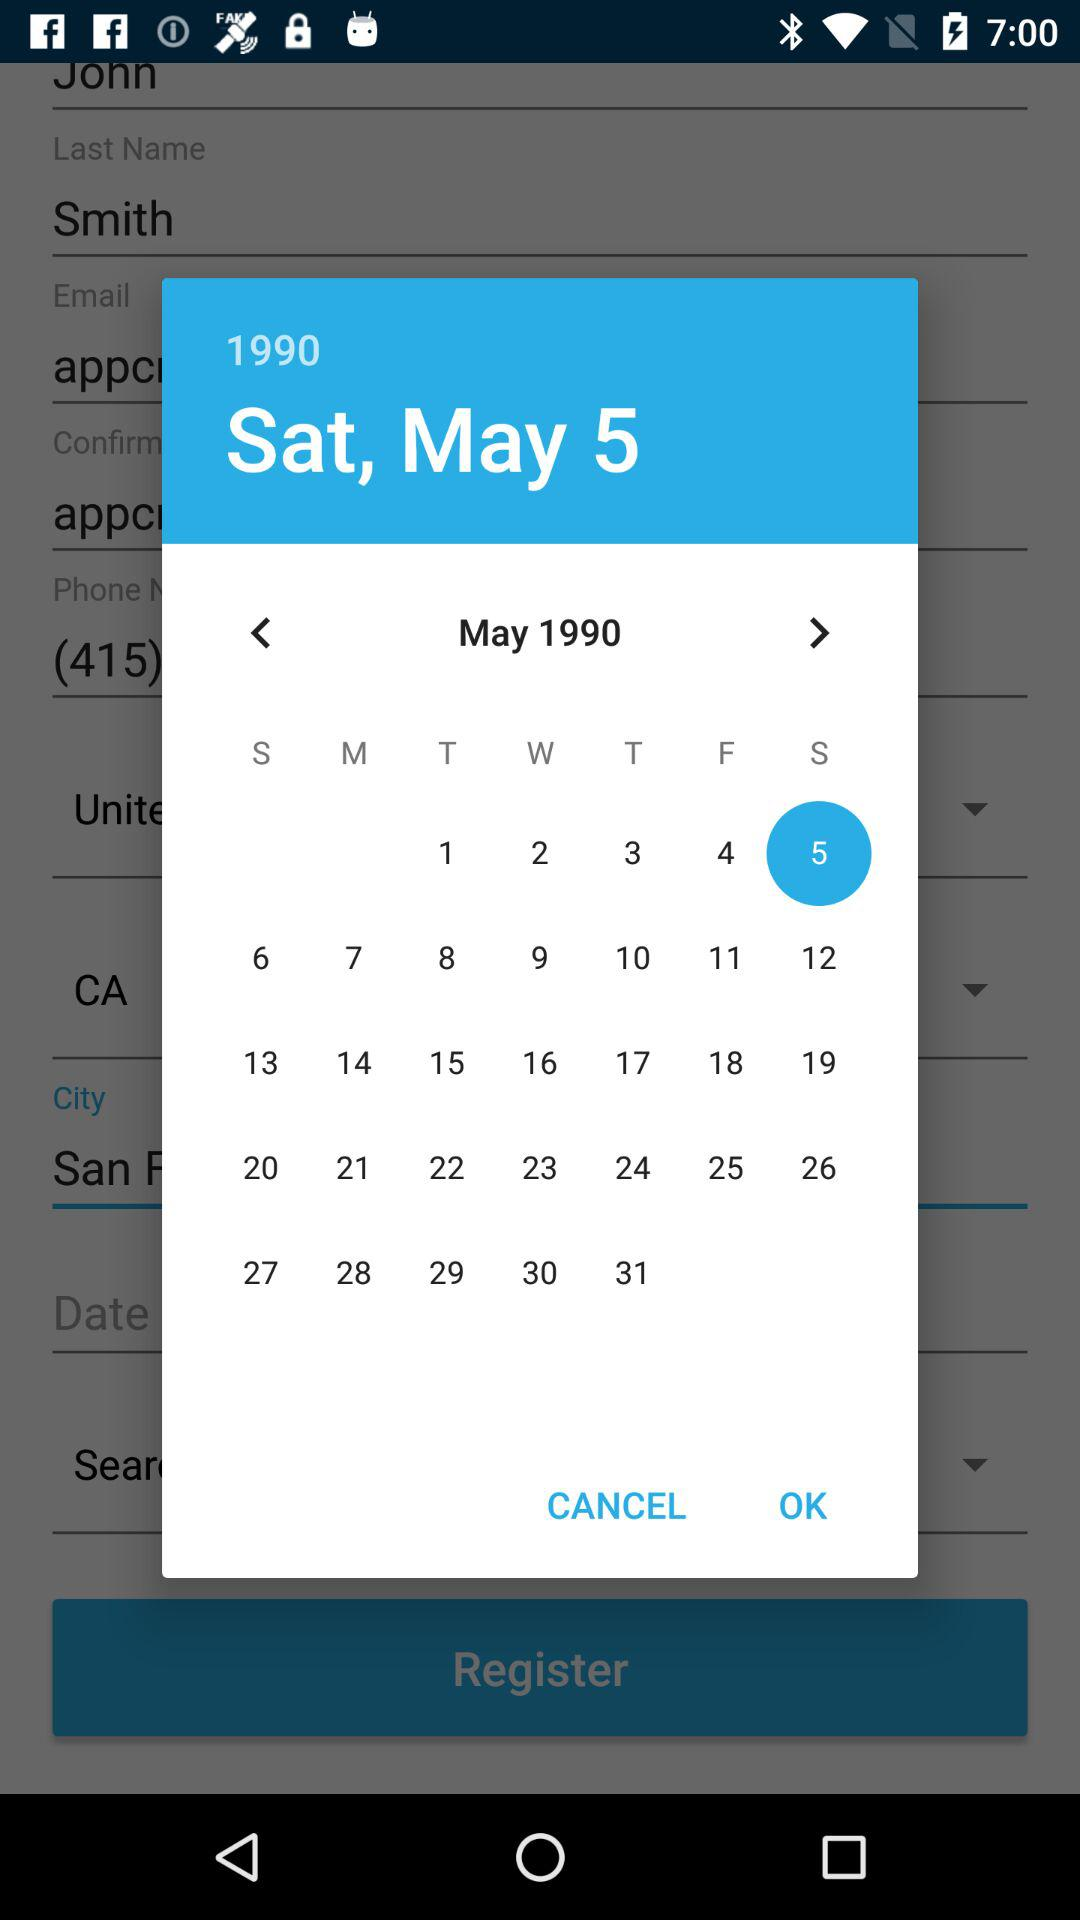How old is John Smith?
When the provided information is insufficient, respond with <no answer>. <no answer> 